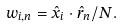<formula> <loc_0><loc_0><loc_500><loc_500>w _ { i , n } = { \hat { x } } _ { i } \cdot { \hat { r } } _ { n } / N .</formula> 